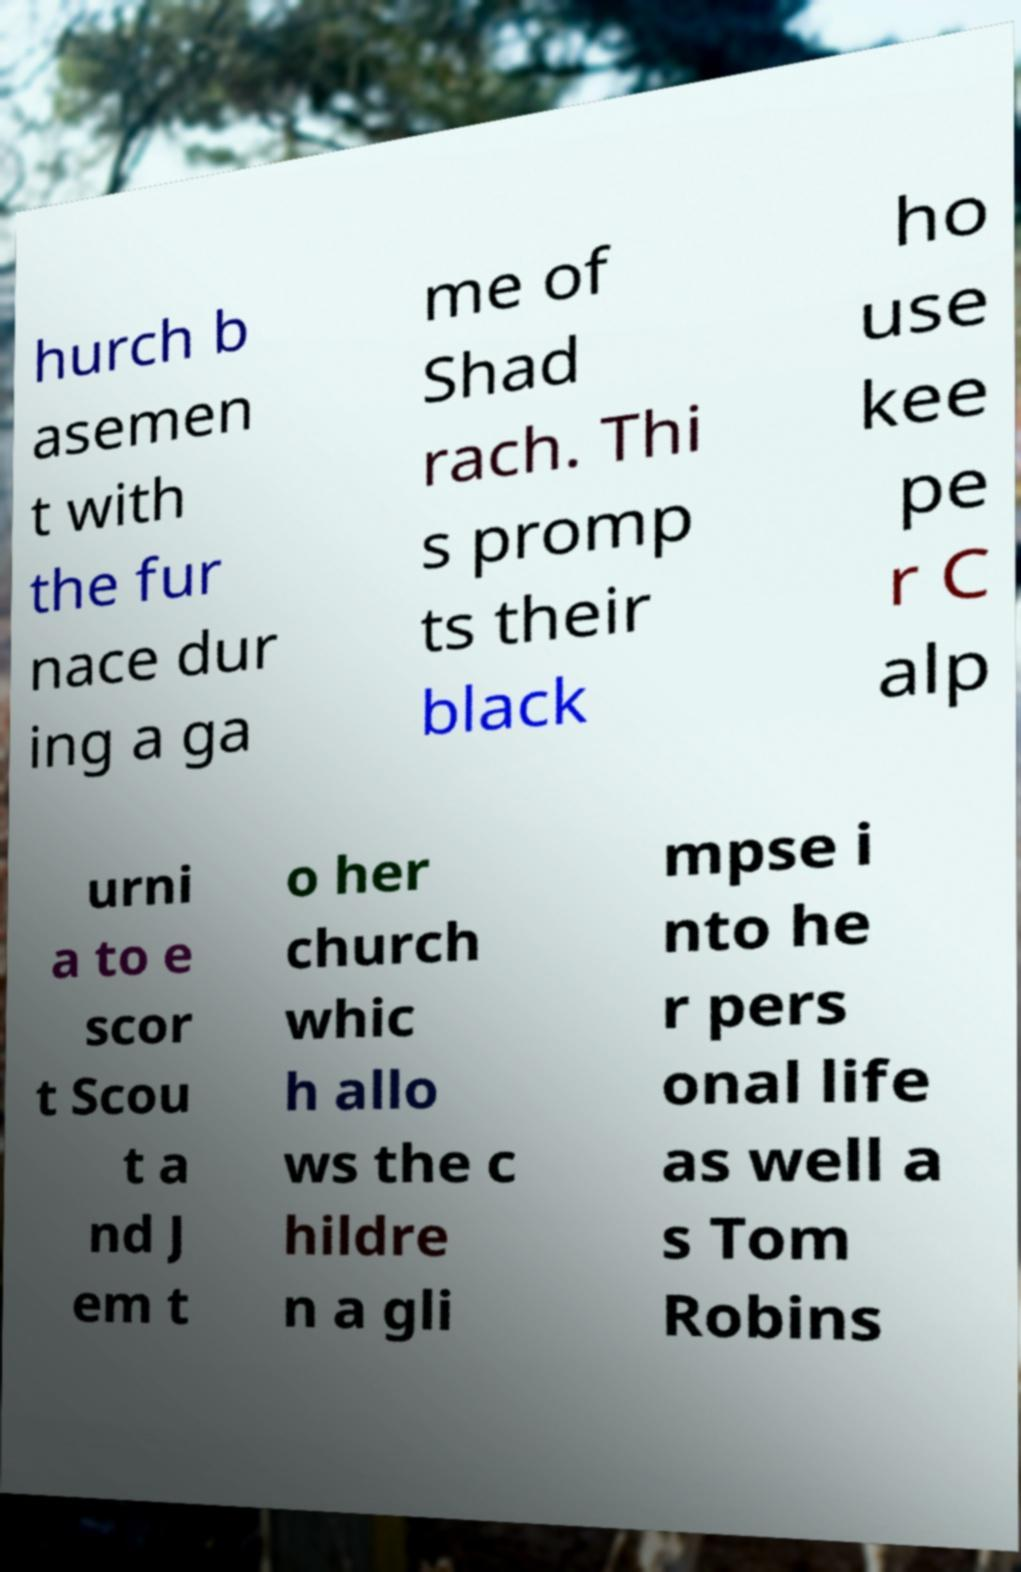I need the written content from this picture converted into text. Can you do that? hurch b asemen t with the fur nace dur ing a ga me of Shad rach. Thi s promp ts their black ho use kee pe r C alp urni a to e scor t Scou t a nd J em t o her church whic h allo ws the c hildre n a gli mpse i nto he r pers onal life as well a s Tom Robins 